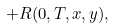<formula> <loc_0><loc_0><loc_500><loc_500>+ R ( 0 , T , x , y ) , \quad \,</formula> 